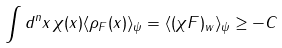<formula> <loc_0><loc_0><loc_500><loc_500>\int d ^ { n } x \, \chi ( x ) \langle \rho _ { F } ( x ) \rangle _ { \psi } = \langle ( \chi F ) _ { w } \rangle _ { \psi } \geq - C</formula> 